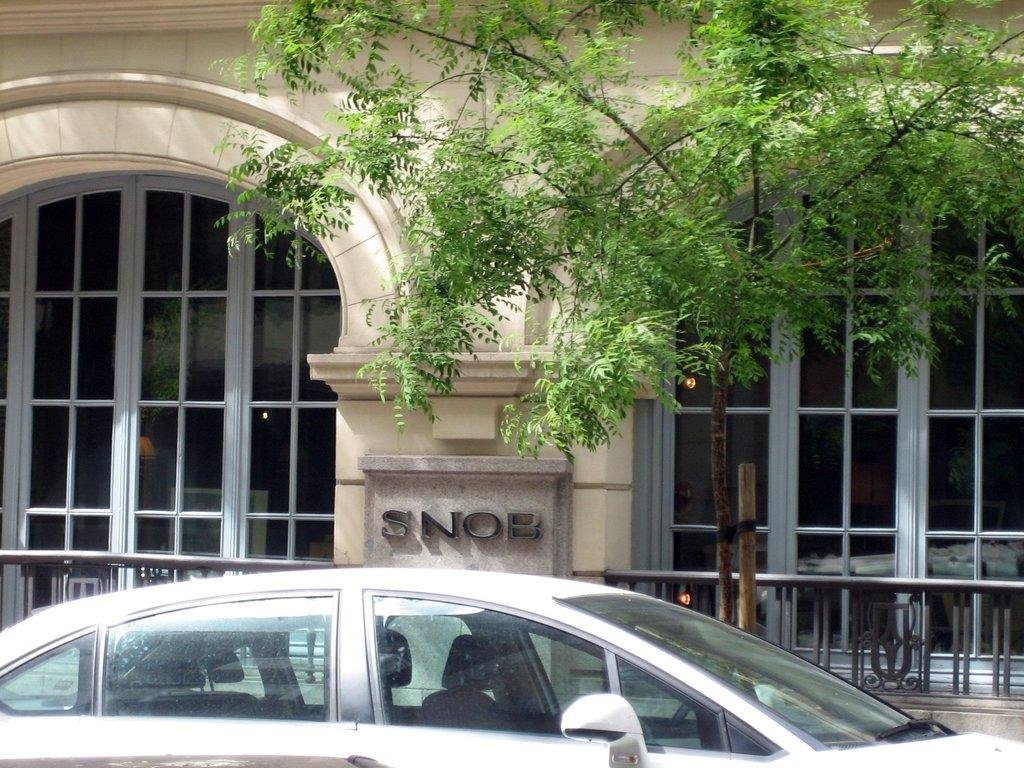What type of vehicle is present in the image? There is a car in the image. What kind of structure can be seen in the image? There is a building with glass windows in the image. What objects are used for cooking in the image? There are grills in the image. What type of plant is visible in the image? There is a tree in the image. What is the purpose of the stone with a name written on it in the image? The purpose of the stone with a name written on it is not clear from the image alone, but it might be a marker or a memorial. How many dolls are sitting on the grills in the image? There are no dolls present in the image; it features a car, a building, grills, a tree, and a stone with a name written on it. 